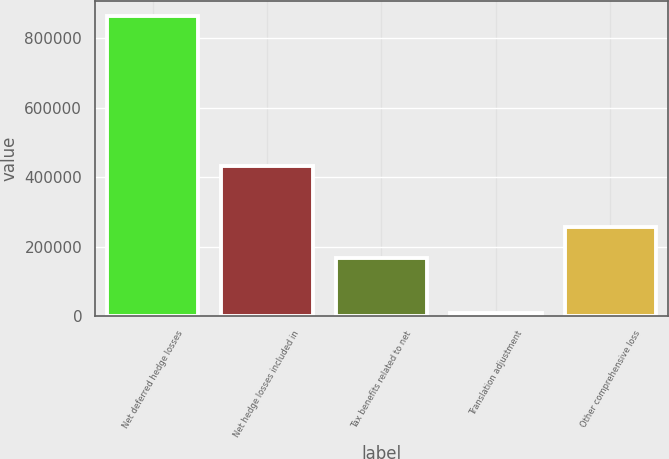<chart> <loc_0><loc_0><loc_500><loc_500><bar_chart><fcel>Net deferred hedge losses<fcel>Net hedge losses included in<fcel>Tax benefits related to net<fcel>Translation adjustment<fcel>Other comprehensive loss<nl><fcel>863439<fcel>431581<fcel>166572<fcel>8118<fcel>257168<nl></chart> 